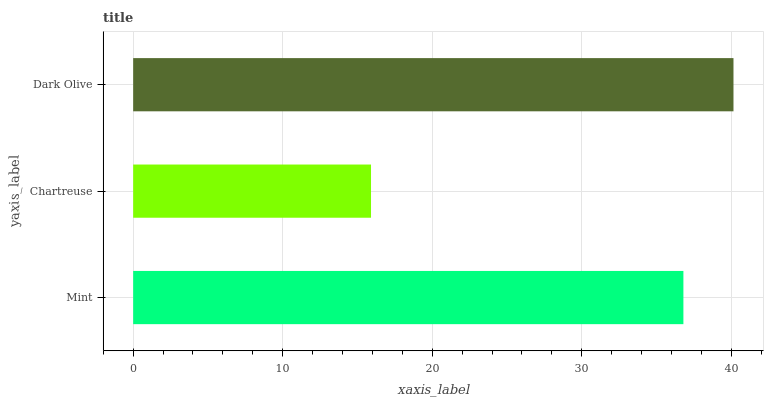Is Chartreuse the minimum?
Answer yes or no. Yes. Is Dark Olive the maximum?
Answer yes or no. Yes. Is Dark Olive the minimum?
Answer yes or no. No. Is Chartreuse the maximum?
Answer yes or no. No. Is Dark Olive greater than Chartreuse?
Answer yes or no. Yes. Is Chartreuse less than Dark Olive?
Answer yes or no. Yes. Is Chartreuse greater than Dark Olive?
Answer yes or no. No. Is Dark Olive less than Chartreuse?
Answer yes or no. No. Is Mint the high median?
Answer yes or no. Yes. Is Mint the low median?
Answer yes or no. Yes. Is Dark Olive the high median?
Answer yes or no. No. Is Dark Olive the low median?
Answer yes or no. No. 